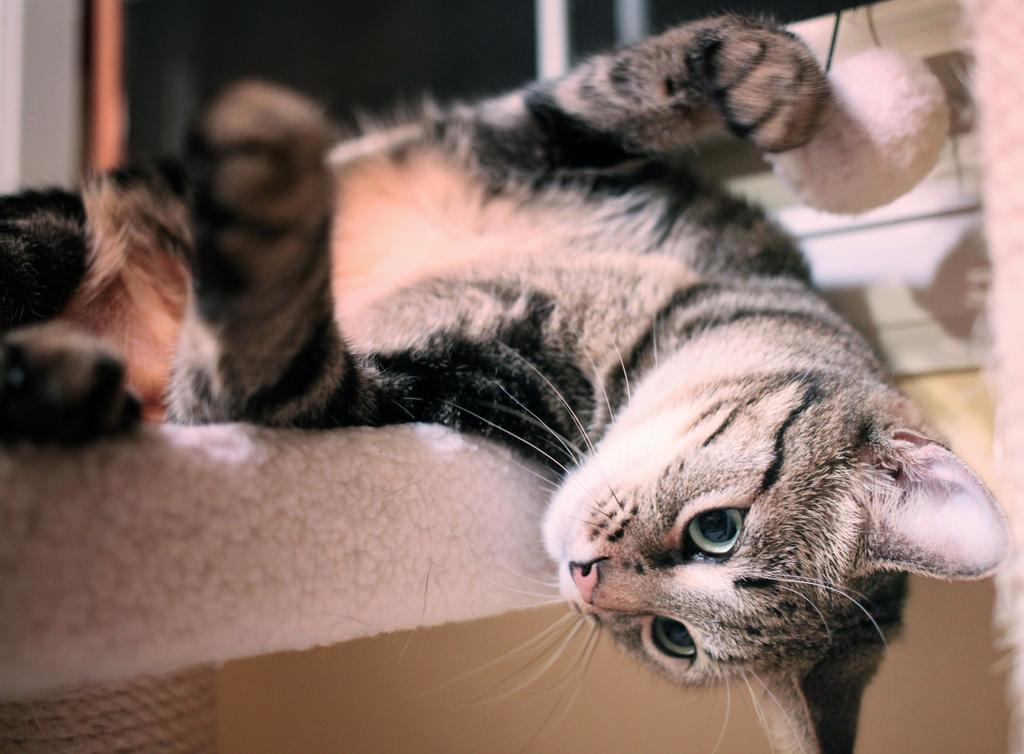Describe this image in one or two sentences. Cat is laying on this white surface. Background it is blur. 